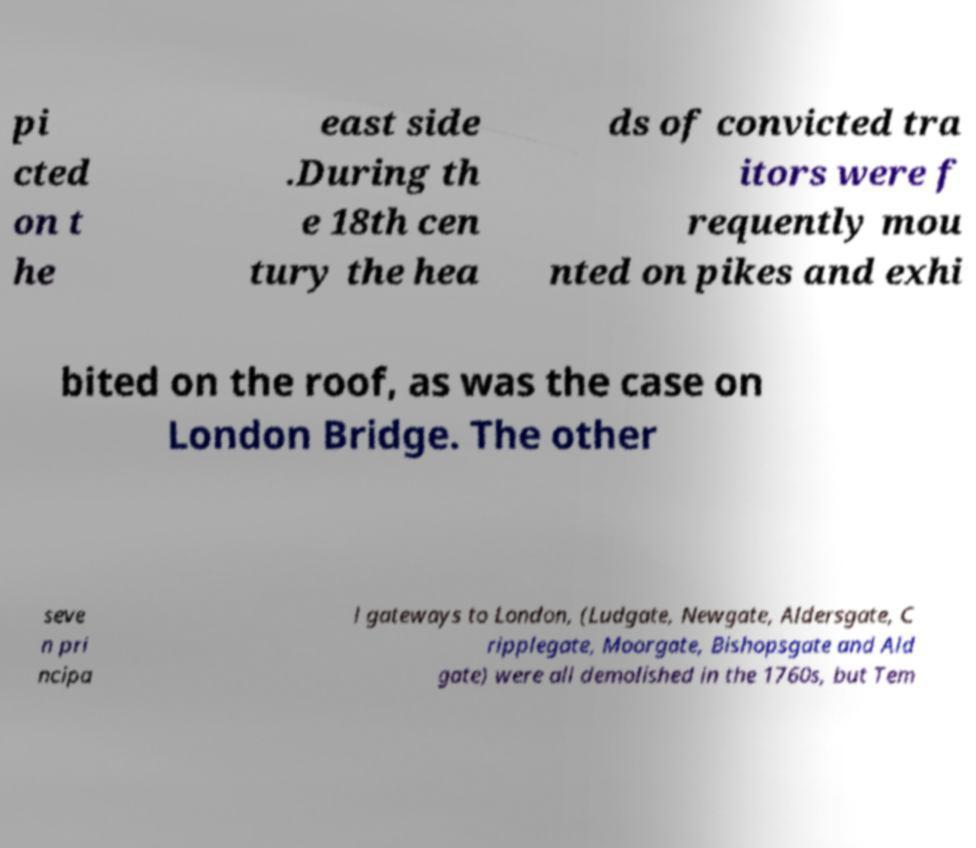What messages or text are displayed in this image? I need them in a readable, typed format. pi cted on t he east side .During th e 18th cen tury the hea ds of convicted tra itors were f requently mou nted on pikes and exhi bited on the roof, as was the case on London Bridge. The other seve n pri ncipa l gateways to London, (Ludgate, Newgate, Aldersgate, C ripplegate, Moorgate, Bishopsgate and Ald gate) were all demolished in the 1760s, but Tem 